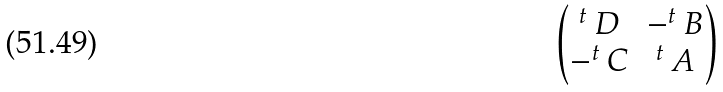<formula> <loc_0><loc_0><loc_500><loc_500>\begin{pmatrix} ^ { t } \, D & - ^ { t } \, B \\ - ^ { t } \, C & ^ { t } \, A \end{pmatrix}</formula> 